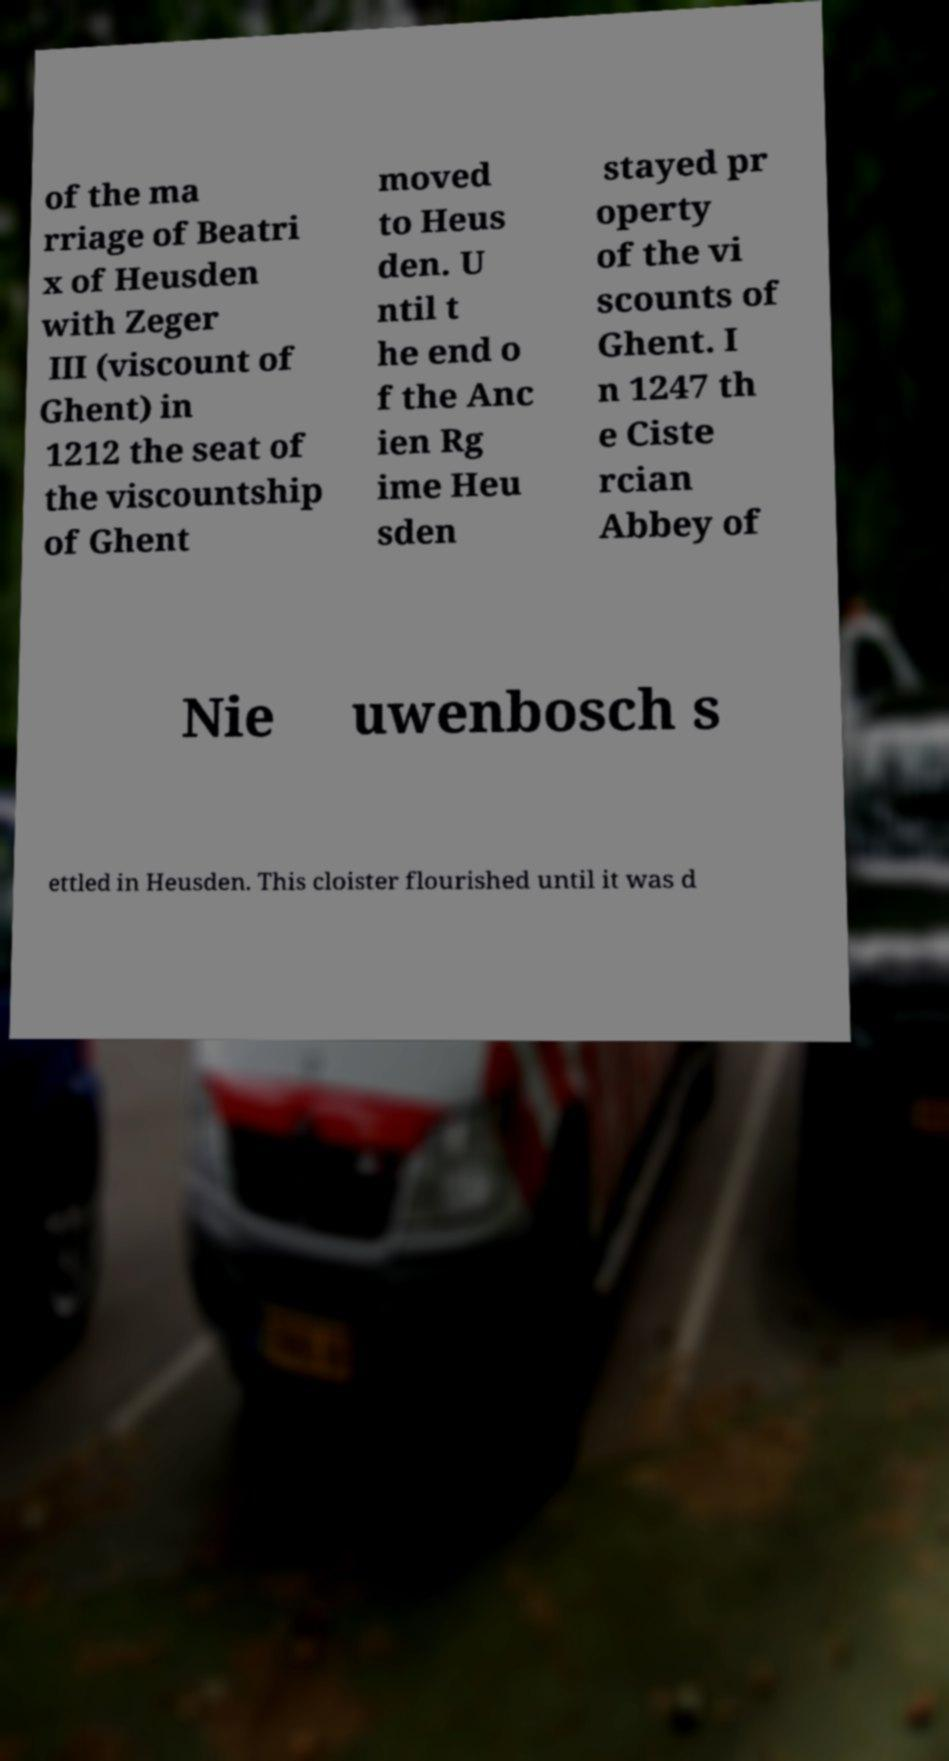Could you assist in decoding the text presented in this image and type it out clearly? of the ma rriage of Beatri x of Heusden with Zeger III (viscount of Ghent) in 1212 the seat of the viscountship of Ghent moved to Heus den. U ntil t he end o f the Anc ien Rg ime Heu sden stayed pr operty of the vi scounts of Ghent. I n 1247 th e Ciste rcian Abbey of Nie uwenbosch s ettled in Heusden. This cloister flourished until it was d 